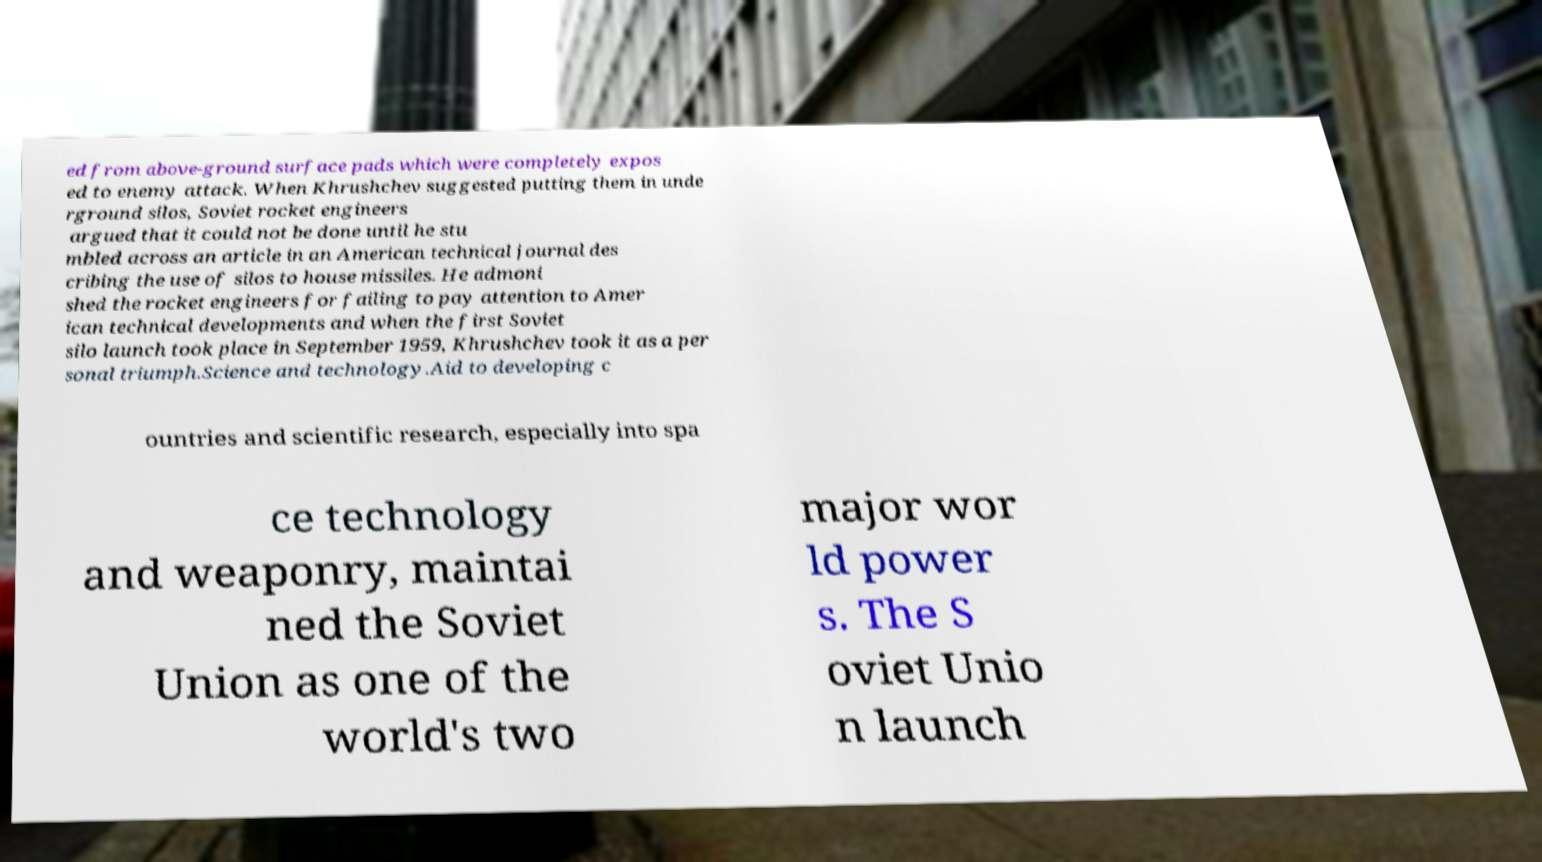Could you extract and type out the text from this image? ed from above-ground surface pads which were completely expos ed to enemy attack. When Khrushchev suggested putting them in unde rground silos, Soviet rocket engineers argued that it could not be done until he stu mbled across an article in an American technical journal des cribing the use of silos to house missiles. He admoni shed the rocket engineers for failing to pay attention to Amer ican technical developments and when the first Soviet silo launch took place in September 1959, Khrushchev took it as a per sonal triumph.Science and technology.Aid to developing c ountries and scientific research, especially into spa ce technology and weaponry, maintai ned the Soviet Union as one of the world's two major wor ld power s. The S oviet Unio n launch 